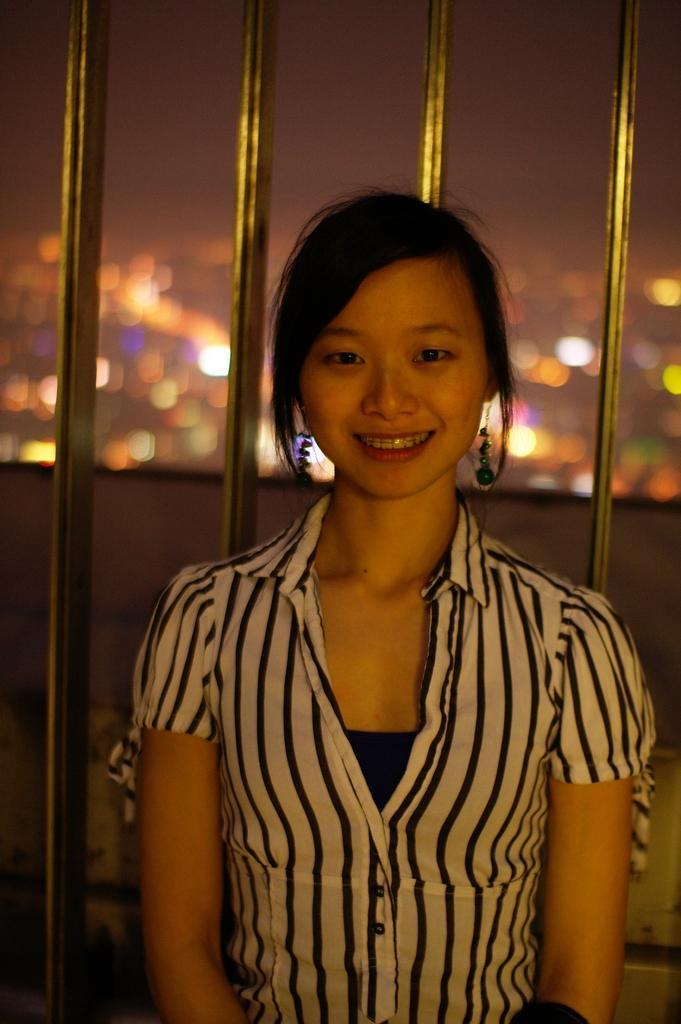Who is present in the image? There is a woman in the image. What is the woman doing in the image? The woman is smiling in the image. What is the woman wearing in the image? The woman is wearing a white and black color shirt in the image. What can be seen in the background of the image? There are bars and lights in the background of the image. How much wealth is displayed in the image? There is no indication of wealth in the image; it features a woman smiling and wearing a shirt, with bars and lights in the background. 